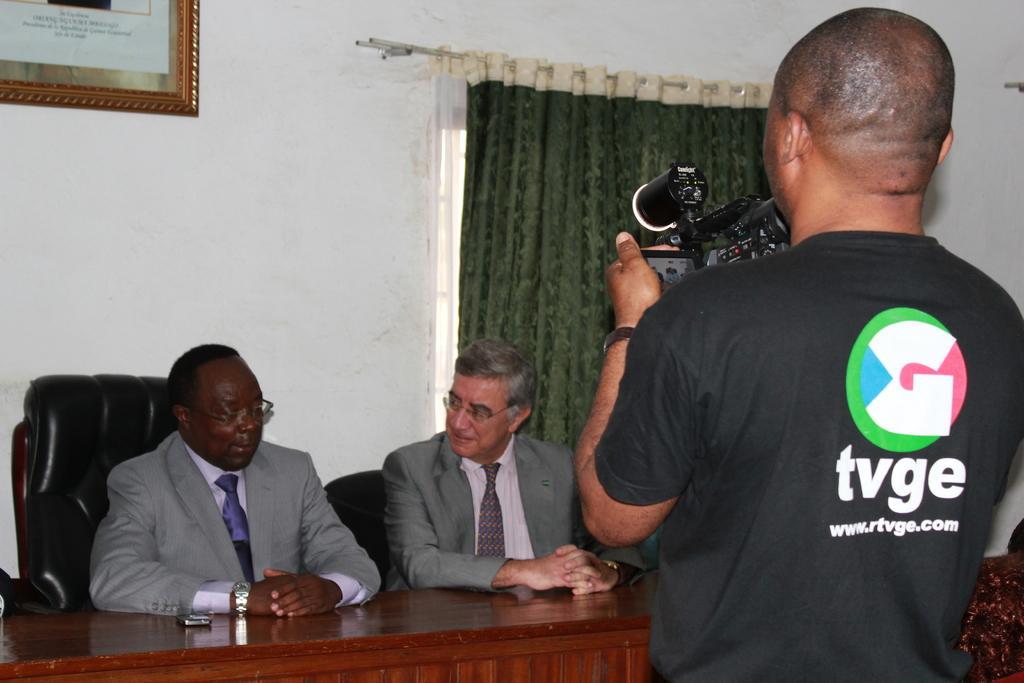Could you give a brief overview of what you see in this image? A person is standing at the right wearing a black t shirt and holding a camera. 2 people are sitting on the black chairs wearing suit. There is a table in front of them. There is a green curtain and a photo frame on a white wall. 